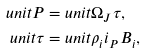<formula> <loc_0><loc_0><loc_500><loc_500>\ u n i t { P } = & \ u n i t { \Omega _ { J } \tau } , \\ \ u n i t { \tau } = & \ u n i t { \rho _ { i } i _ { P } B _ { i } } ,</formula> 